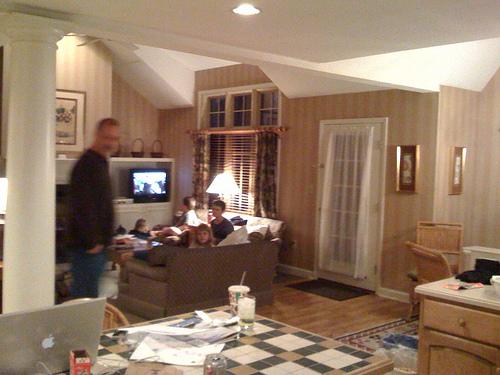Who is in the room?
Short answer required. Family. What room are the men in?
Give a very brief answer. Living room. How many drawers are visible?
Give a very brief answer. 1. Is this picture blurry?
Quick response, please. Yes. Is there anyone in the room?
Answer briefly. Yes. Are there people here?
Quick response, please. Yes. How many people are in this picture?
Quick response, please. 5. What is the man doing?
Concise answer only. Standing. How many people can be seen?
Keep it brief. 5. What is shown on the TV screen?
Write a very short answer. Tv show. How many kids attend this class?
Keep it brief. 4. 